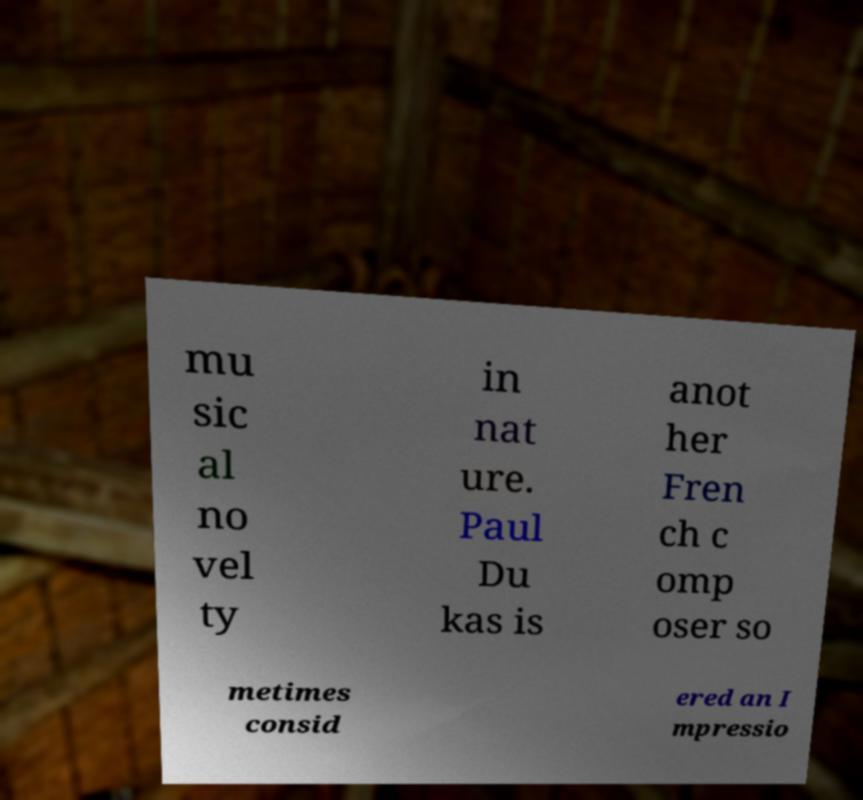For documentation purposes, I need the text within this image transcribed. Could you provide that? mu sic al no vel ty in nat ure. Paul Du kas is anot her Fren ch c omp oser so metimes consid ered an I mpressio 